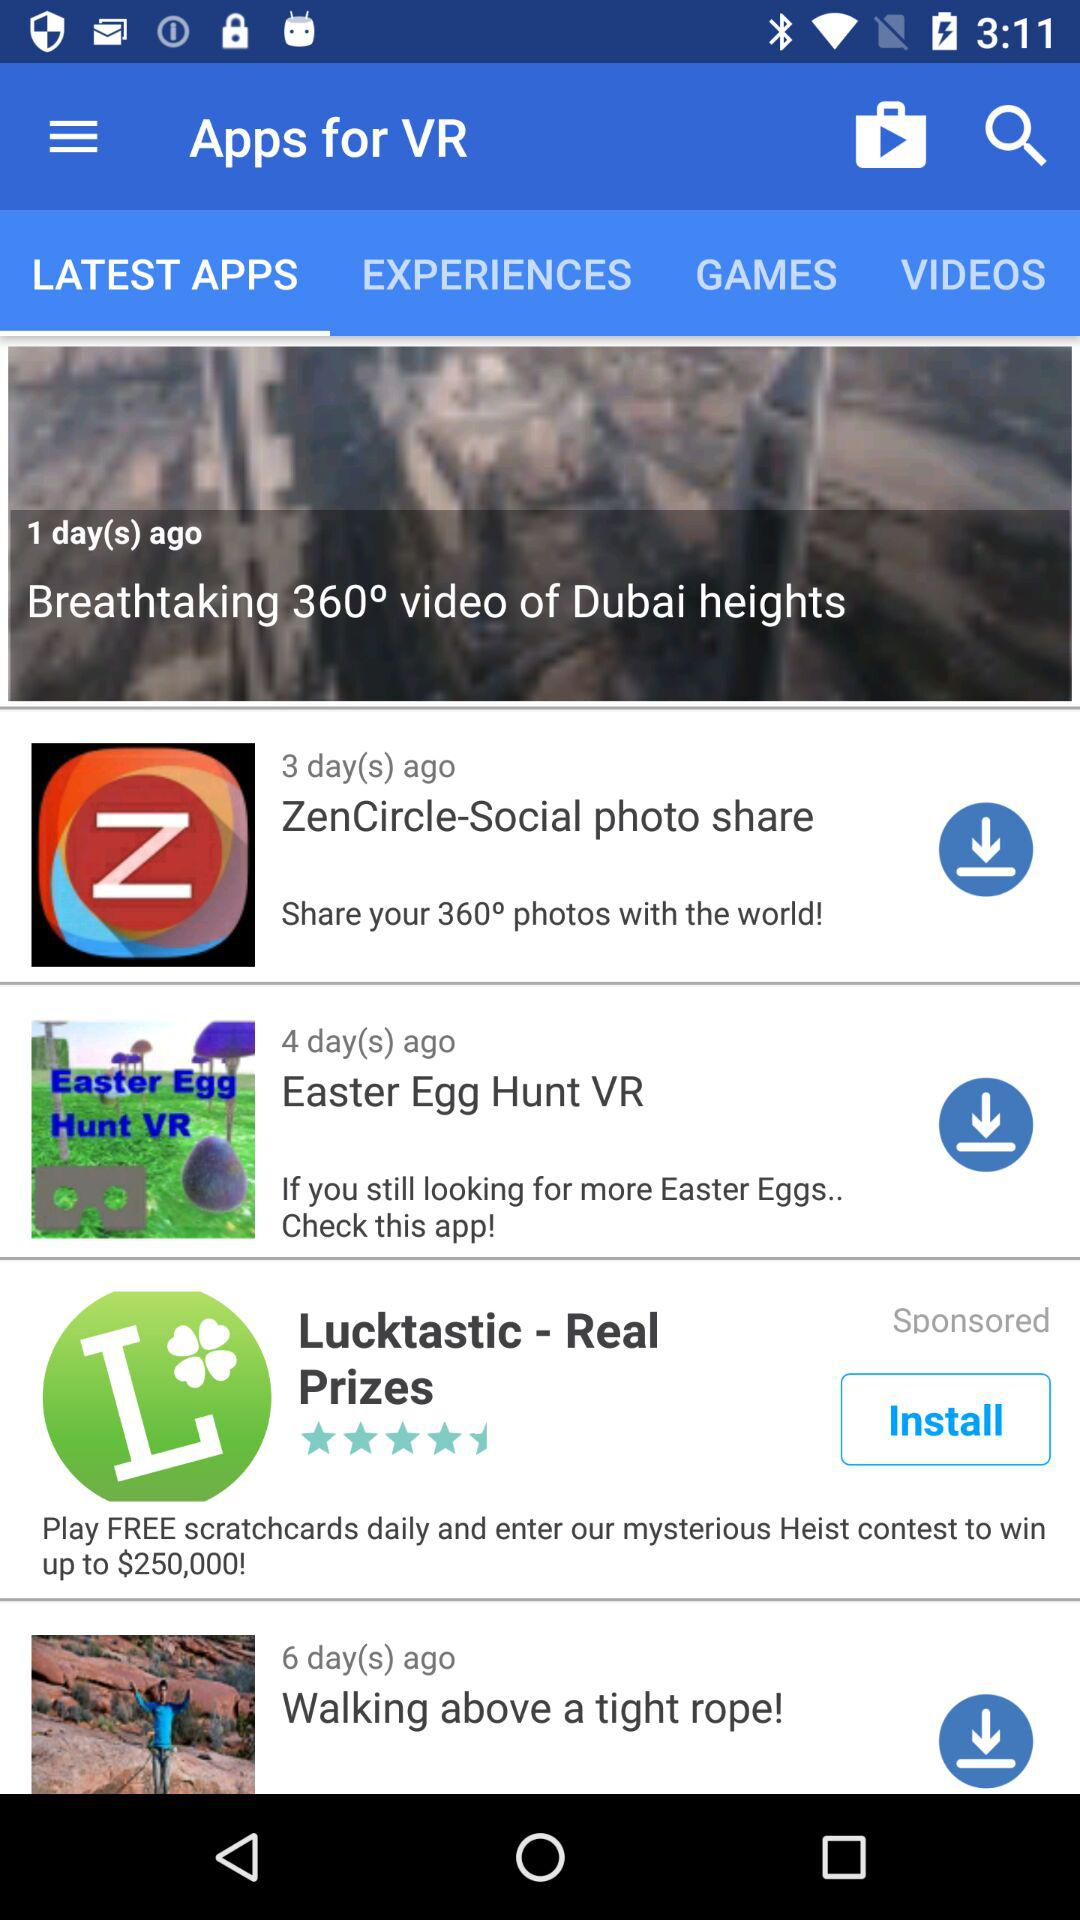How many apps are there that are sponsored?
Answer the question using a single word or phrase. 1 